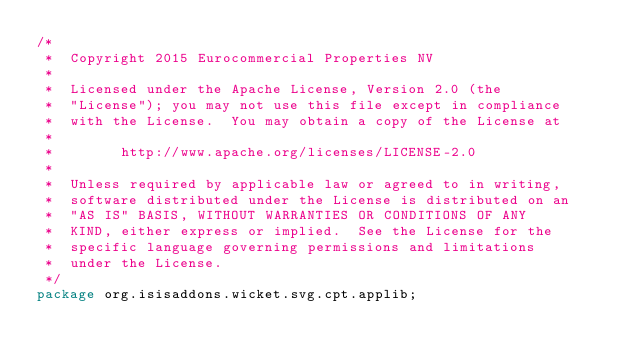Convert code to text. <code><loc_0><loc_0><loc_500><loc_500><_Java_>/*
 *  Copyright 2015 Eurocommercial Properties NV
 *
 *  Licensed under the Apache License, Version 2.0 (the
 *  "License"); you may not use this file except in compliance
 *  with the License.  You may obtain a copy of the License at
 *
 *        http://www.apache.org/licenses/LICENSE-2.0
 *
 *  Unless required by applicable law or agreed to in writing,
 *  software distributed under the License is distributed on an
 *  "AS IS" BASIS, WITHOUT WARRANTIES OR CONDITIONS OF ANY
 *  KIND, either express or implied.  See the License for the
 *  specific language governing permissions and limitations
 *  under the License.
 */
package org.isisaddons.wicket.svg.cpt.applib;
</code> 